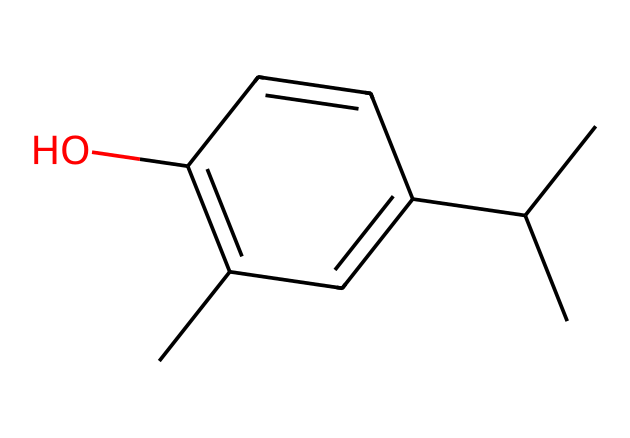What is the molecular formula of thymol? By analyzing the structure through the provided SMILES, we can identify the number of carbon (C), hydrogen (H), and oxygen (O) atoms. In this case, there are 10 carbon atoms, 14 hydrogen atoms, and 1 oxygen atom, leading to the molecular formula C10H14O.
Answer: C10H14O How many rings are present in the structure of thymol? From the SMILES representation, we note that there is a cyclic structure indicated by the numbered "1", which implies the presence of one ring in the chemical structure.
Answer: 1 Does thymol have any alcohol functional groups? In the structure, we can see the presence of an –OH group attached to one of the carbon atoms, which confirms that thymol has an alcohol functional group.
Answer: Yes What type of chemical is thymol classified as? Based on the presence of the –OH group and the aromatic ring in the structure, thymol is classified as a phenol because it contains both a hydroxyl group and an aromatic ring.
Answer: Phenol What is the significance of the hydroxyl group in thymol? The hydroxyl group contributes to the polarity of the molecule, enhancing its solubility in water and being responsible for its antibacterial properties as it interacts with microbial cell membranes.
Answer: Antimicrobial properties How many double bonds are present in the structure of thymol? By examining the SMILES representation, we can identify the presence of two double bonds connected between carbon atoms in the ring structure, leading to the conclusion that there are two double bonds.
Answer: 2 